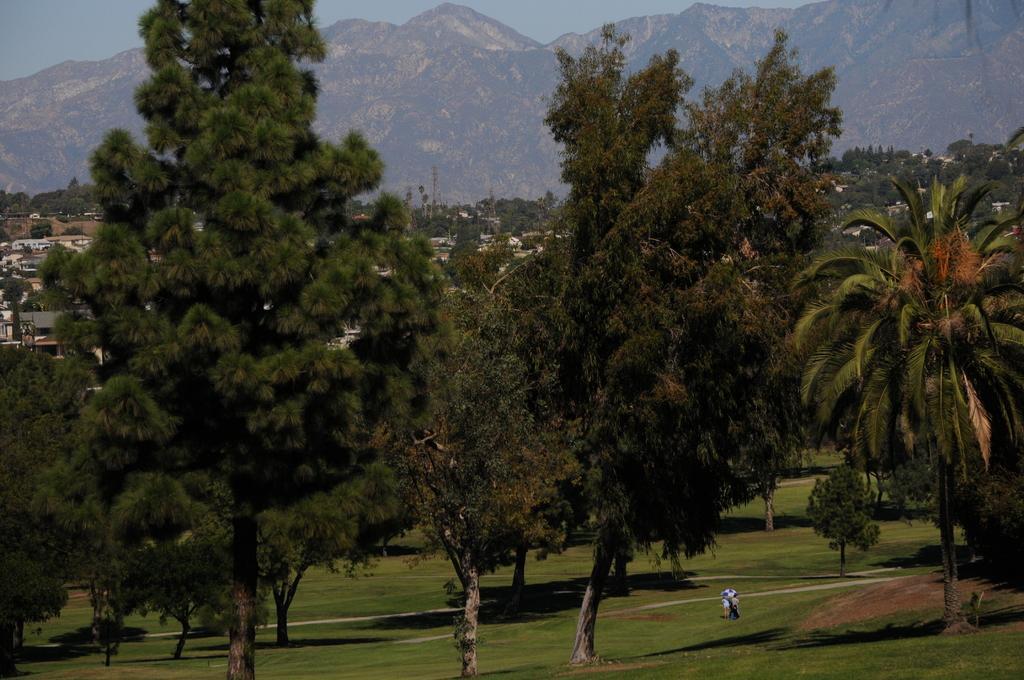Please provide a concise description of this image. This is grass and there are three persons on the ground. Here we can see trees, houses, and mountain. In the background there is sky. 